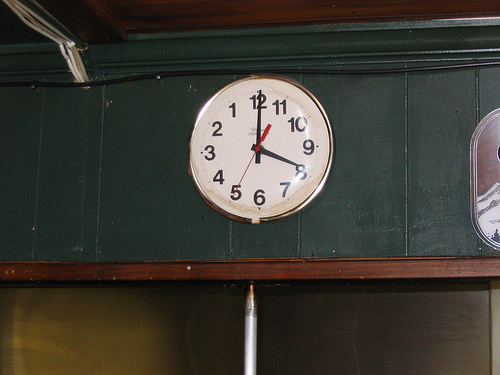<image>
Is there a clock on the wall? Yes. Looking at the image, I can see the clock is positioned on top of the wall, with the wall providing support. 